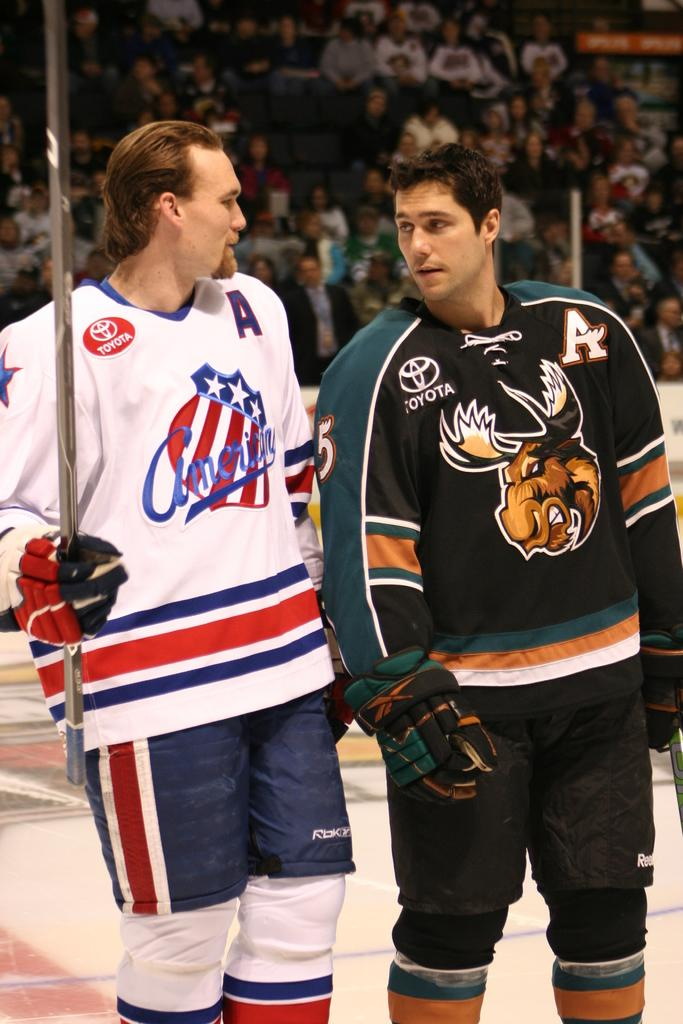How many people are in the image? There are two men in the image. What are the men wearing? The men are wearing jerseys. What position are the men in? The men are standing. Where might this image have been taken? The image appears to be taken in a stadium. What can be seen in the background of the image? There is a huge crowd in the background of the image. What is at the bottom of the image? There is a ground at the bottom of the image. What book is the mom reading in the garden in the image? There is no book, mom, or garden present in the image. 